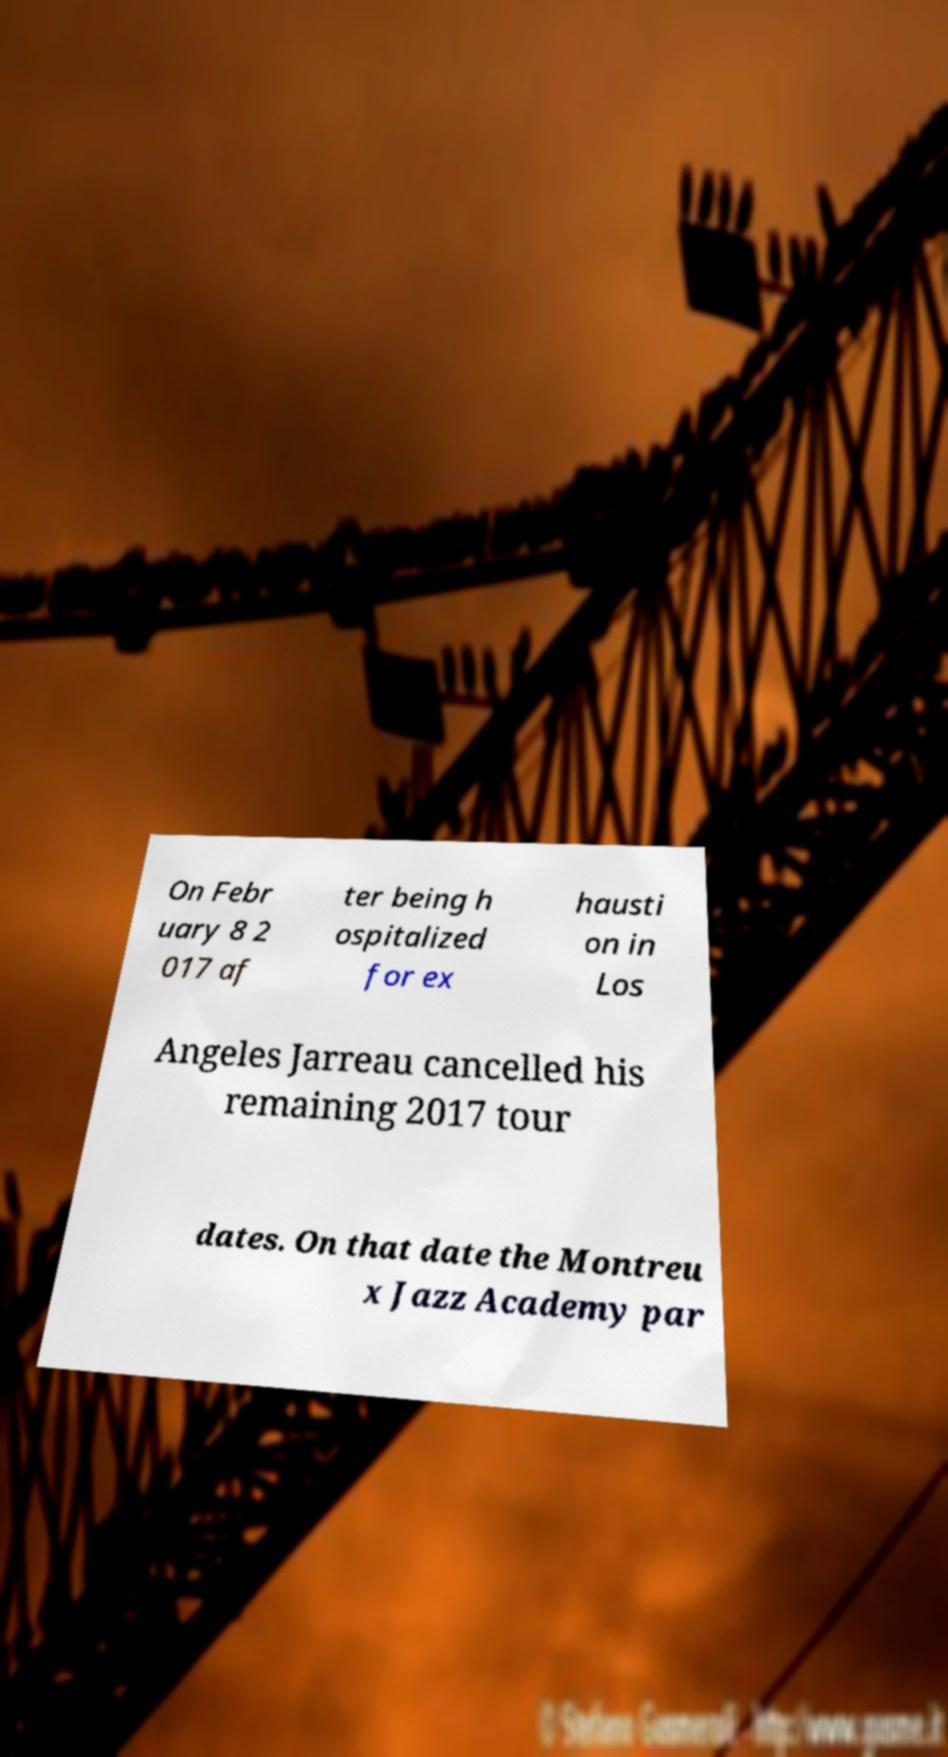Please read and relay the text visible in this image. What does it say? On Febr uary 8 2 017 af ter being h ospitalized for ex hausti on in Los Angeles Jarreau cancelled his remaining 2017 tour dates. On that date the Montreu x Jazz Academy par 